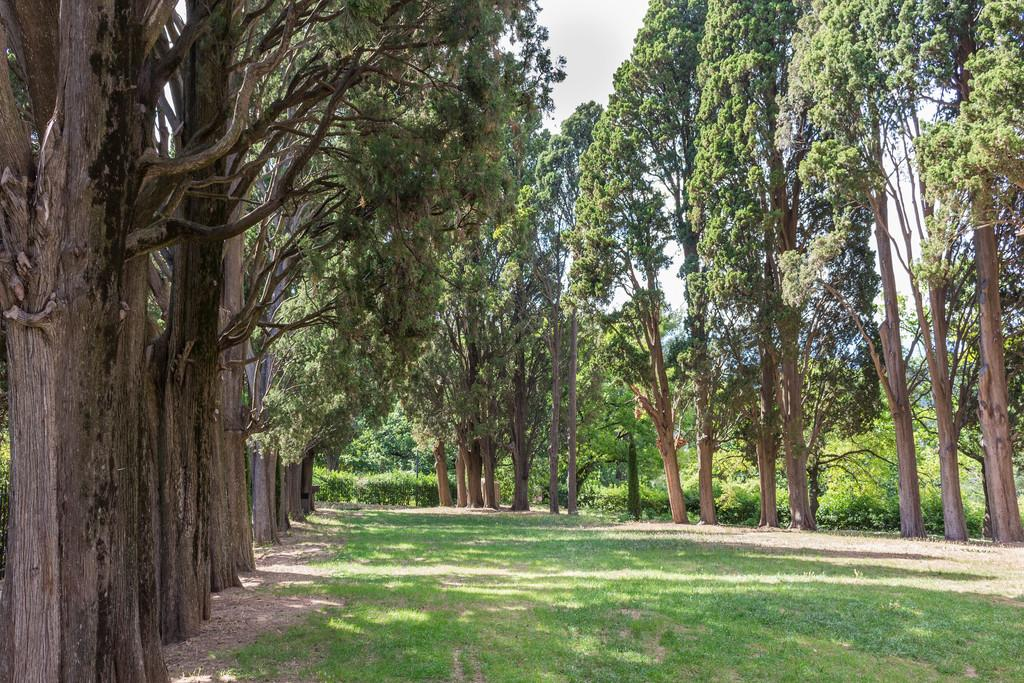What type of vegetation is present in the image? There are trees in the image. What is covering the ground in the image? There is grass on the ground in the image. How would you describe the sky in the image? The sky is cloudy in the image. Can you see any spots on the sea in the image? There is no sea present in the image, so it is not possible to see any spots on it. 